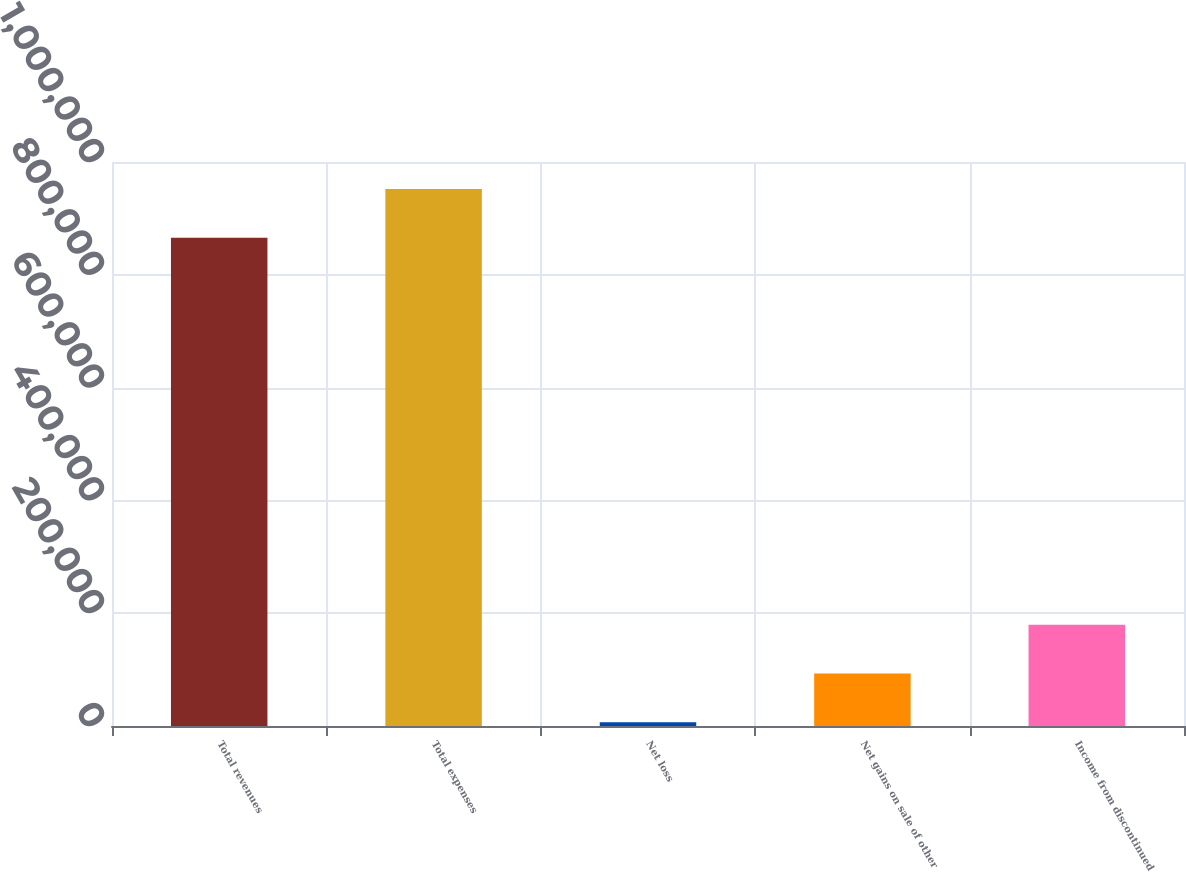<chart> <loc_0><loc_0><loc_500><loc_500><bar_chart><fcel>Total revenues<fcel>Total expenses<fcel>Net loss<fcel>Net gains on sale of other<fcel>Income from discontinued<nl><fcel>865584<fcel>952142<fcel>6592<fcel>93150.4<fcel>179709<nl></chart> 